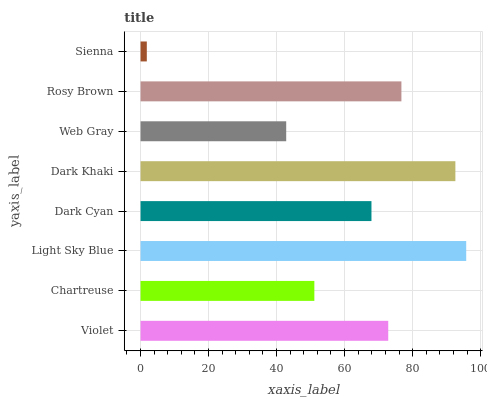Is Sienna the minimum?
Answer yes or no. Yes. Is Light Sky Blue the maximum?
Answer yes or no. Yes. Is Chartreuse the minimum?
Answer yes or no. No. Is Chartreuse the maximum?
Answer yes or no. No. Is Violet greater than Chartreuse?
Answer yes or no. Yes. Is Chartreuse less than Violet?
Answer yes or no. Yes. Is Chartreuse greater than Violet?
Answer yes or no. No. Is Violet less than Chartreuse?
Answer yes or no. No. Is Violet the high median?
Answer yes or no. Yes. Is Dark Cyan the low median?
Answer yes or no. Yes. Is Rosy Brown the high median?
Answer yes or no. No. Is Light Sky Blue the low median?
Answer yes or no. No. 